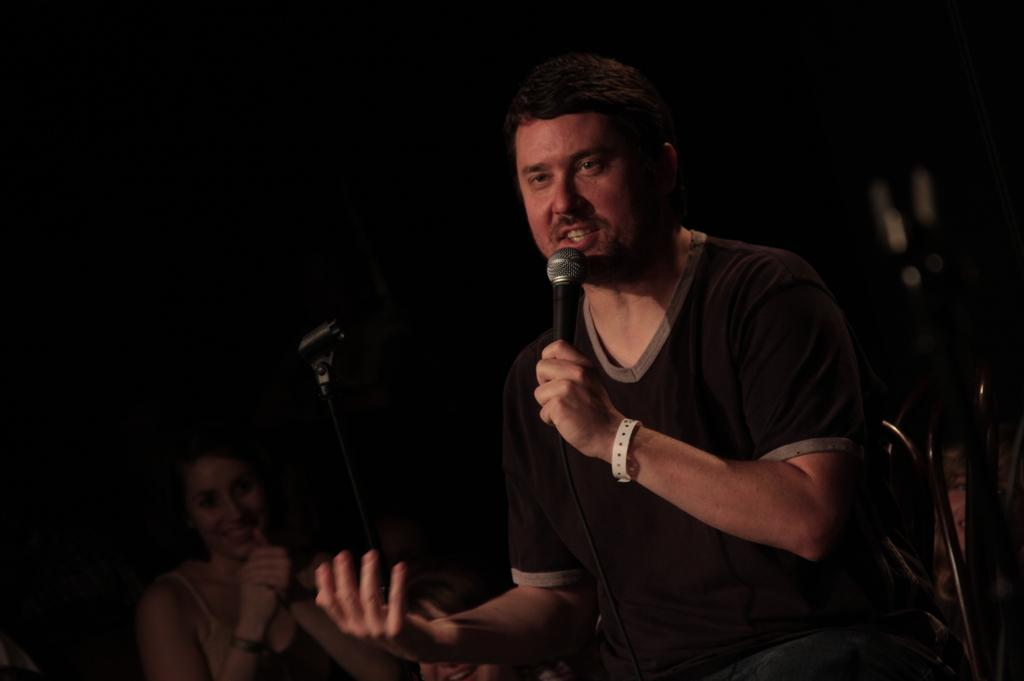What is the man in the image holding in his hand? The man is holding a microphone in his hand. Can you describe the woman in the image? The image only shows a woman, but no specific details about her are provided. What might the man be doing with the microphone? The man might be using the microphone to speak or perform, given that he is holding it. What type of mask is the woman wearing in the image? There is no mention of a mask in the image, so it cannot be determined if the woman is wearing one. 